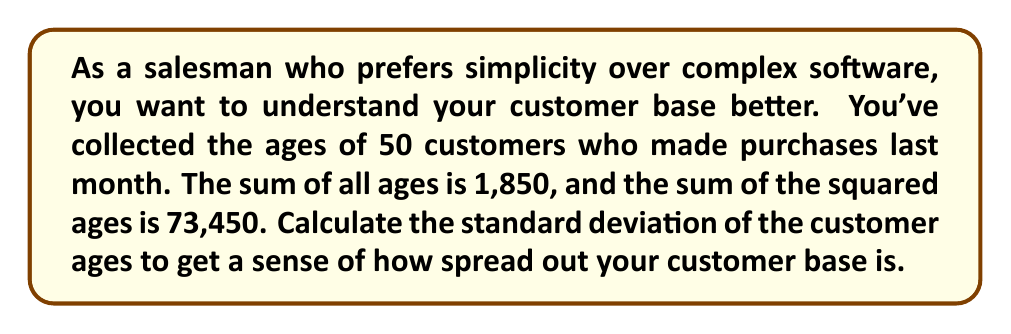Can you solve this math problem? Let's break this down into simple steps:

1) First, we need to calculate the mean (average) age:
   Mean ($\mu$) = Sum of ages / Number of customers
   $\mu = 1850 / 50 = 37$ years

2) Now, we need to use the formula for standard deviation:
   $$ \sigma = \sqrt{\frac{\sum x^2}{n} - \mu^2} $$
   Where:
   $\sigma$ is the standard deviation
   $\sum x^2$ is the sum of squared ages
   $n$ is the number of customers
   $\mu$ is the mean we calculated

3) Let's plug in our values:
   $$ \sigma = \sqrt{\frac{73450}{50} - 37^2} $$

4) Simplify inside the square root:
   $$ \sigma = \sqrt{1469 - 1369} $$

5) Subtract inside the square root:
   $$ \sigma = \sqrt{100} $$

6) Take the square root:
   $$ \sigma = 10 $$

So, the standard deviation of customer ages is 10 years.
Answer: 10 years 